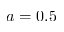Convert formula to latex. <formula><loc_0><loc_0><loc_500><loc_500>a = 0 . 5</formula> 